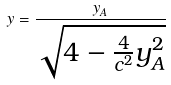<formula> <loc_0><loc_0><loc_500><loc_500>y = \frac { y _ { A } } { \sqrt { 4 - \frac { 4 } { c ^ { 2 } } y _ { A } ^ { 2 } } }</formula> 